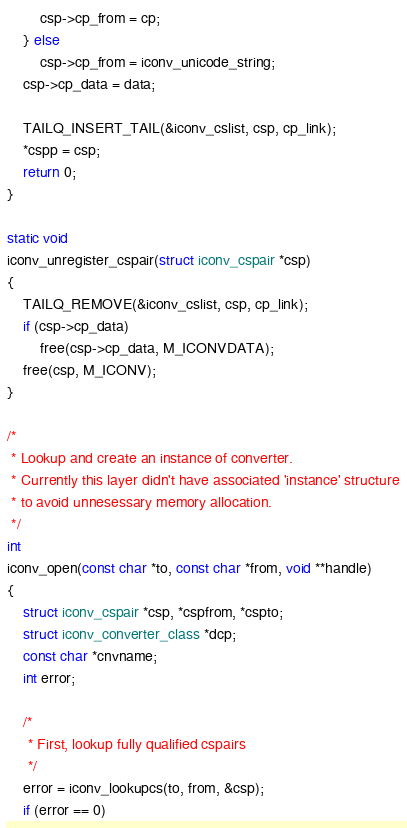Convert code to text. <code><loc_0><loc_0><loc_500><loc_500><_C_>		csp->cp_from = cp;
	} else
		csp->cp_from = iconv_unicode_string;
	csp->cp_data = data;

	TAILQ_INSERT_TAIL(&iconv_cslist, csp, cp_link);
	*cspp = csp;
	return 0;
}

static void
iconv_unregister_cspair(struct iconv_cspair *csp)
{
	TAILQ_REMOVE(&iconv_cslist, csp, cp_link);
	if (csp->cp_data)
		free(csp->cp_data, M_ICONVDATA);
	free(csp, M_ICONV);
}

/*
 * Lookup and create an instance of converter.
 * Currently this layer didn't have associated 'instance' structure
 * to avoid unnesessary memory allocation.
 */
int
iconv_open(const char *to, const char *from, void **handle)
{
	struct iconv_cspair *csp, *cspfrom, *cspto;
	struct iconv_converter_class *dcp;
	const char *cnvname;
	int error;

	/*
	 * First, lookup fully qualified cspairs
	 */
	error = iconv_lookupcs(to, from, &csp);
	if (error == 0)</code> 